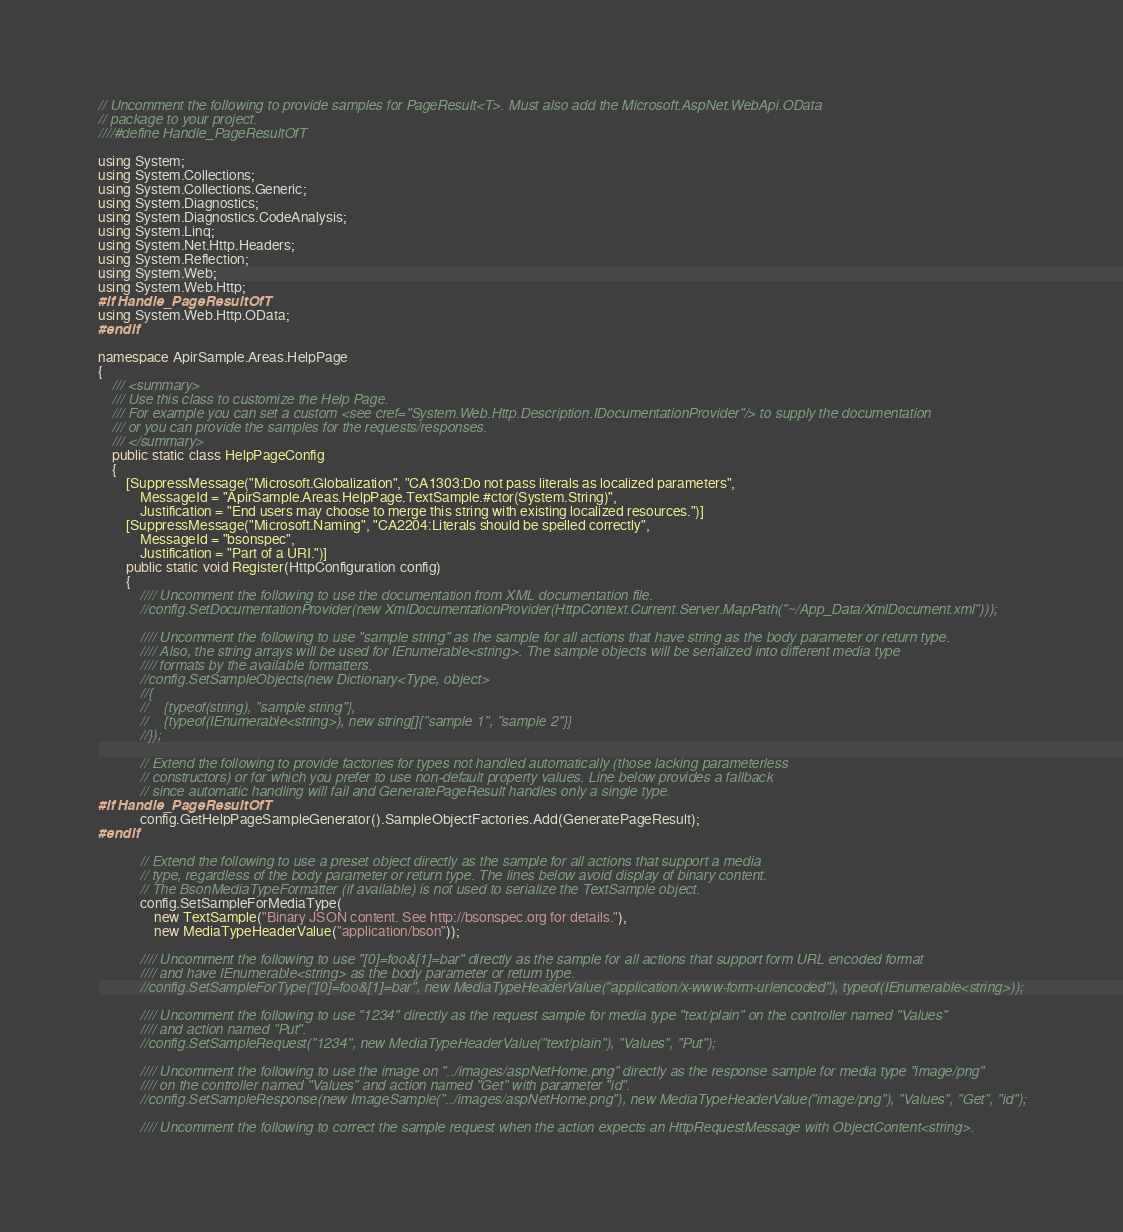Convert code to text. <code><loc_0><loc_0><loc_500><loc_500><_C#_>// Uncomment the following to provide samples for PageResult<T>. Must also add the Microsoft.AspNet.WebApi.OData
// package to your project.
////#define Handle_PageResultOfT

using System;
using System.Collections;
using System.Collections.Generic;
using System.Diagnostics;
using System.Diagnostics.CodeAnalysis;
using System.Linq;
using System.Net.Http.Headers;
using System.Reflection;
using System.Web;
using System.Web.Http;
#if Handle_PageResultOfT
using System.Web.Http.OData;
#endif

namespace ApirSample.Areas.HelpPage
{
    /// <summary>
    /// Use this class to customize the Help Page.
    /// For example you can set a custom <see cref="System.Web.Http.Description.IDocumentationProvider"/> to supply the documentation
    /// or you can provide the samples for the requests/responses.
    /// </summary>
    public static class HelpPageConfig
    {
        [SuppressMessage("Microsoft.Globalization", "CA1303:Do not pass literals as localized parameters",
            MessageId = "ApirSample.Areas.HelpPage.TextSample.#ctor(System.String)",
            Justification = "End users may choose to merge this string with existing localized resources.")]
        [SuppressMessage("Microsoft.Naming", "CA2204:Literals should be spelled correctly",
            MessageId = "bsonspec",
            Justification = "Part of a URI.")]
        public static void Register(HttpConfiguration config)
        {
            //// Uncomment the following to use the documentation from XML documentation file.
            //config.SetDocumentationProvider(new XmlDocumentationProvider(HttpContext.Current.Server.MapPath("~/App_Data/XmlDocument.xml")));

            //// Uncomment the following to use "sample string" as the sample for all actions that have string as the body parameter or return type.
            //// Also, the string arrays will be used for IEnumerable<string>. The sample objects will be serialized into different media type 
            //// formats by the available formatters.
            //config.SetSampleObjects(new Dictionary<Type, object>
            //{
            //    {typeof(string), "sample string"},
            //    {typeof(IEnumerable<string>), new string[]{"sample 1", "sample 2"}}
            //});

            // Extend the following to provide factories for types not handled automatically (those lacking parameterless
            // constructors) or for which you prefer to use non-default property values. Line below provides a fallback
            // since automatic handling will fail and GeneratePageResult handles only a single type.
#if Handle_PageResultOfT
            config.GetHelpPageSampleGenerator().SampleObjectFactories.Add(GeneratePageResult);
#endif

            // Extend the following to use a preset object directly as the sample for all actions that support a media
            // type, regardless of the body parameter or return type. The lines below avoid display of binary content.
            // The BsonMediaTypeFormatter (if available) is not used to serialize the TextSample object.
            config.SetSampleForMediaType(
                new TextSample("Binary JSON content. See http://bsonspec.org for details."),
                new MediaTypeHeaderValue("application/bson"));

            //// Uncomment the following to use "[0]=foo&[1]=bar" directly as the sample for all actions that support form URL encoded format
            //// and have IEnumerable<string> as the body parameter or return type.
            //config.SetSampleForType("[0]=foo&[1]=bar", new MediaTypeHeaderValue("application/x-www-form-urlencoded"), typeof(IEnumerable<string>));

            //// Uncomment the following to use "1234" directly as the request sample for media type "text/plain" on the controller named "Values"
            //// and action named "Put".
            //config.SetSampleRequest("1234", new MediaTypeHeaderValue("text/plain"), "Values", "Put");

            //// Uncomment the following to use the image on "../images/aspNetHome.png" directly as the response sample for media type "image/png"
            //// on the controller named "Values" and action named "Get" with parameter "id".
            //config.SetSampleResponse(new ImageSample("../images/aspNetHome.png"), new MediaTypeHeaderValue("image/png"), "Values", "Get", "id");

            //// Uncomment the following to correct the sample request when the action expects an HttpRequestMessage with ObjectContent<string>.</code> 